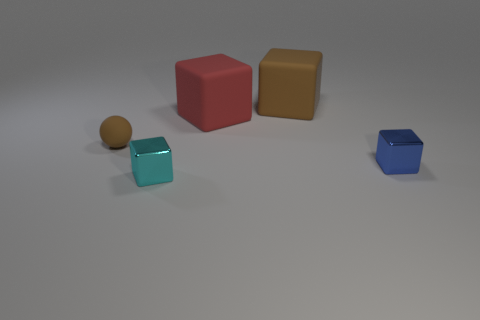What size is the block that is the same color as the tiny sphere?
Provide a short and direct response. Large. What shape is the large rubber thing that is the same color as the tiny matte ball?
Offer a very short reply. Cube. Is the number of tiny blue cubes to the left of the small matte object less than the number of small rubber balls?
Provide a succinct answer. Yes. What is the blue thing made of?
Offer a terse response. Metal. What is the color of the small sphere?
Keep it short and to the point. Brown. There is a rubber object that is both to the right of the brown ball and in front of the brown rubber cube; what is its color?
Provide a short and direct response. Red. Is there any other thing that is the same material as the big brown object?
Ensure brevity in your answer.  Yes. Does the red thing have the same material as the tiny block behind the cyan cube?
Your answer should be compact. No. What is the size of the shiny block left of the small block right of the cyan object?
Keep it short and to the point. Small. Are there any other things of the same color as the tiny matte ball?
Give a very brief answer. Yes. 